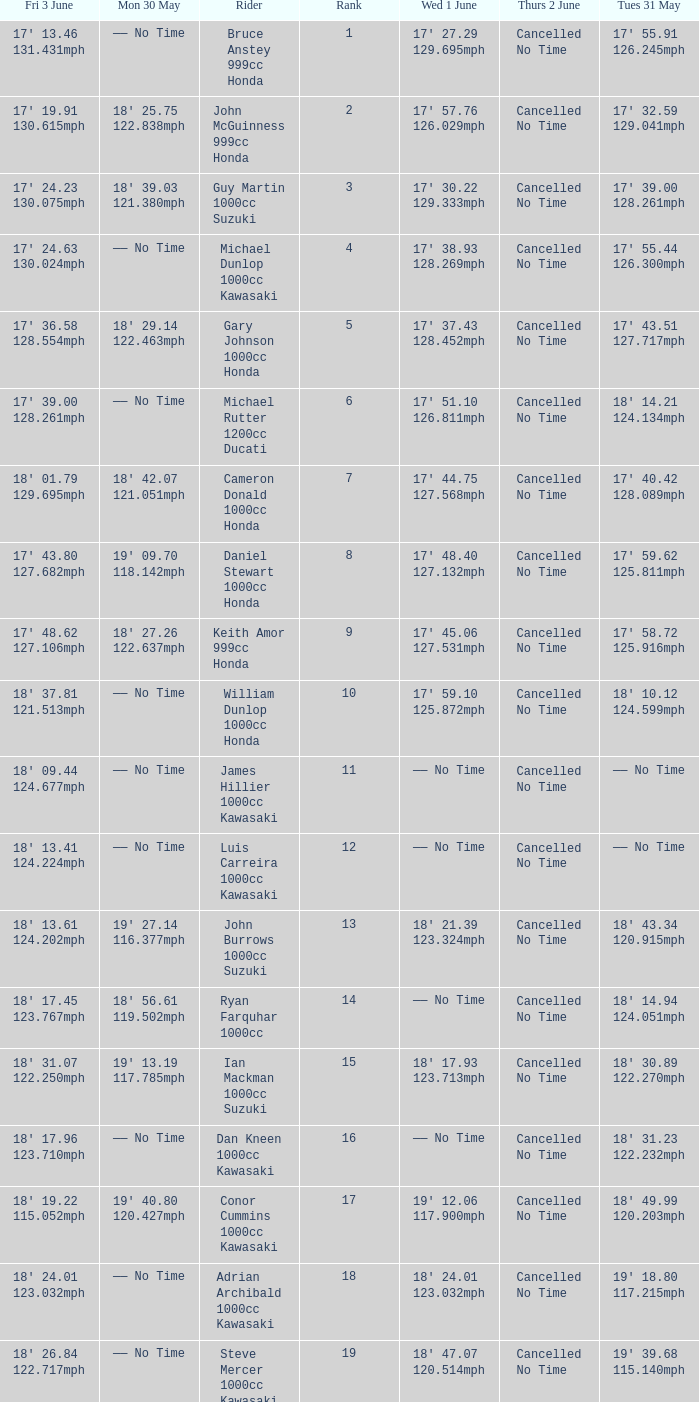What is the Thurs 2 June time for the rider with a Fri 3 June time of 17' 36.58 128.554mph? Cancelled No Time. 